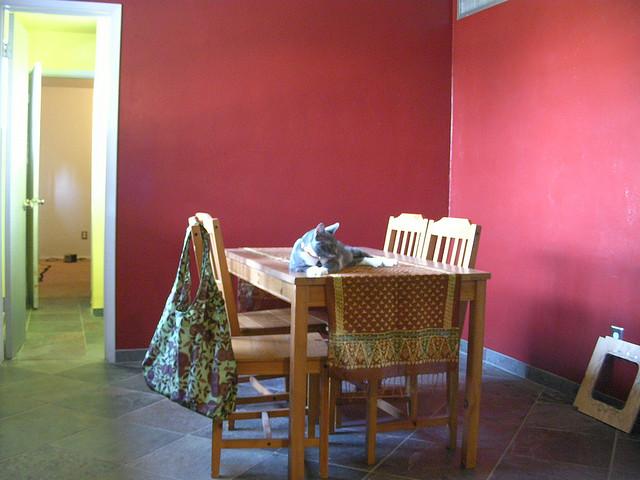How many chair legs are visible?
Short answer required. 8. What is leaning against the wall?
Concise answer only. Frame. What color are the walls around the table?
Answer briefly. Red. 